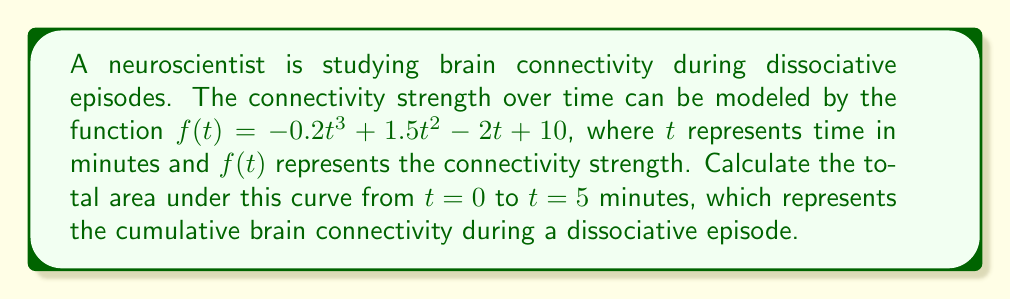Can you solve this math problem? To find the area under the curve, we need to calculate the definite integral of the function $f(t)$ from $t=0$ to $t=5$. Let's approach this step-by-step:

1) The function is $f(t) = -0.2t^3 + 1.5t^2 - 2t + 10$

2) To find the area, we need to integrate this function:

   $$\int_0^5 (-0.2t^3 + 1.5t^2 - 2t + 10) dt$$

3) Let's integrate each term:
   
   $$\int -0.2t^3 dt = -0.05t^4$$
   $$\int 1.5t^2 dt = 0.5t^3$$
   $$\int -2t dt = -t^2$$
   $$\int 10 dt = 10t$$

4) Now our indefinite integral is:

   $$-0.05t^4 + 0.5t^3 - t^2 + 10t + C$$

5) We need to evaluate this from 0 to 5. Let's call our antiderivative F(t):

   $$F(5) - F(0) = (-0.05(5^4) + 0.5(5^3) - 5^2 + 10(5)) - (-0.05(0^4) + 0.5(0^3) - 0^2 + 10(0))$$

6) Simplify:
   
   $$F(5) - F(0) = (-31.25 + 62.5 - 25 + 50) - (0)$$
   $$= 56.25 - 0 = 56.25$$

Therefore, the total area under the curve, representing the cumulative brain connectivity during the dissociative episode, is 56.25 arbitrary units.
Answer: 56.25 arbitrary units 